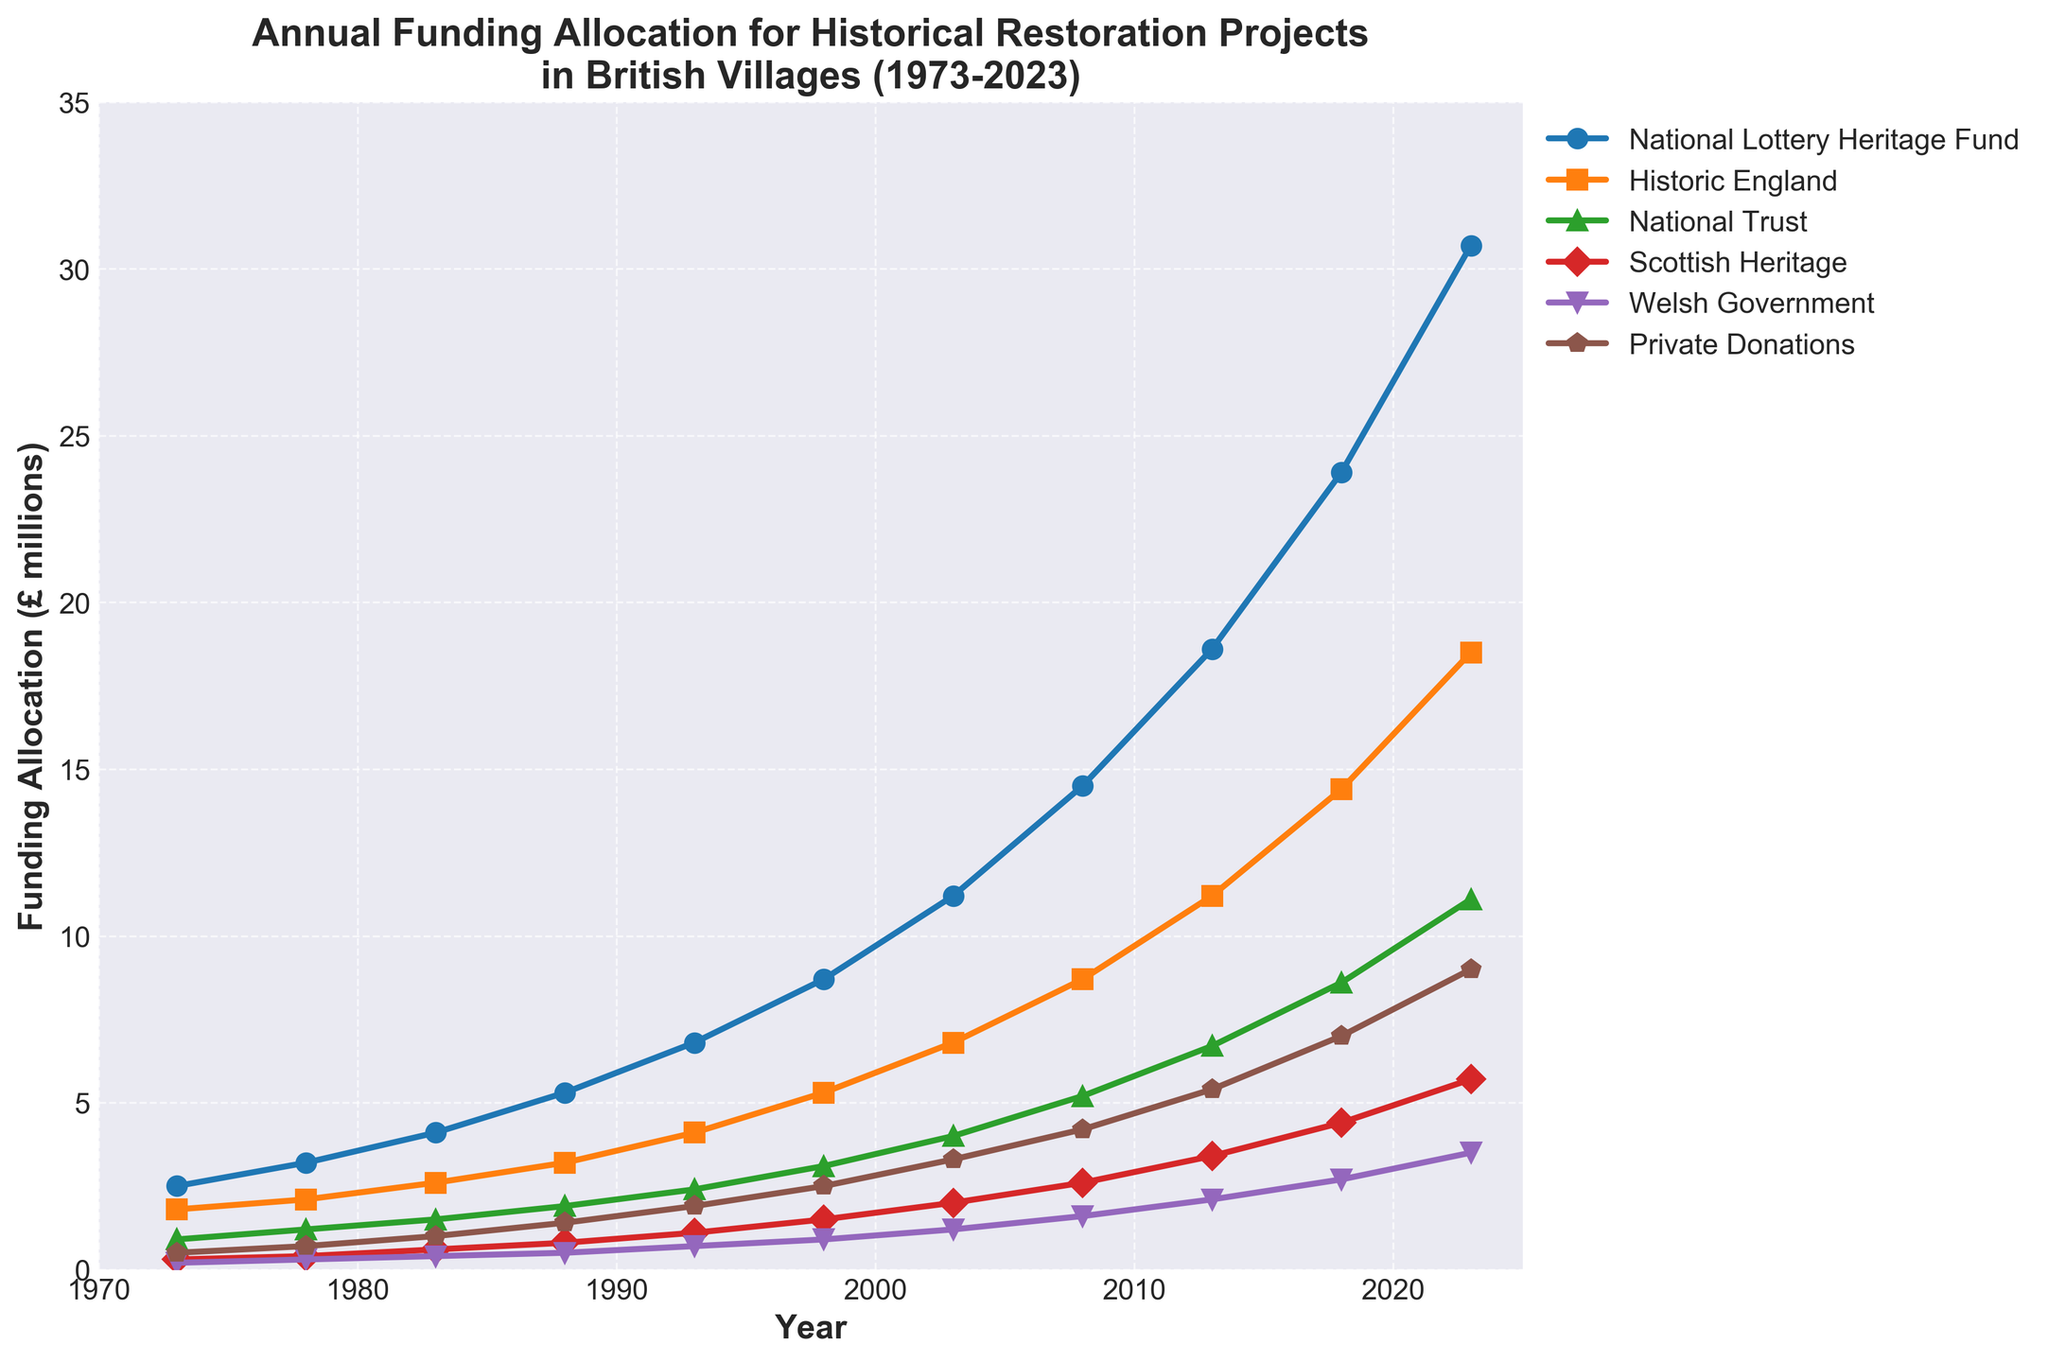What is the total funding allocation for 2023 from all sources combined? Add the funding allocations from each source for the year 2023: £30.7m (National Lottery Heritage Fund) + £18.5m (Historic England) + £11.1m (National Trust) + £5.7m (Scottish Heritage) + £3.5m (Welsh Government) + £9.0m (Private Donations) = £78.5m
Answer: £78.5m Between the National Lottery Heritage Fund and Historic England in 2013, which one had a higher funding allocation and by how much? National Lottery Heritage Fund in 2013 had £18.6m, and Historic England had £11.2m. The difference is £18.6m - £11.2m = £7.4m.
Answer: National Lottery Heritage Fund by £7.4m In which year did the National Trust's funding allocation first exceed £5 million? Look at the National Trust line and identify the first year where the funding crosses £5 million. This occurs in 2008 with £5.2m.
Answer: 2008 How does the trend of Private Donations compare to Welsh Government funding from 1993 to 2023? Both show an upward trend, but Private Donations increase more sharply. In 1993, Private Donations were £1.9m, and Welsh Government was £0.7m. By 2023, Private Donations reached £9.0m, whereas Welsh Government funding increased to £3.5m.
Answer: Private Donations increased more sharply than Welsh Government funding What is the average funding allocation from the National Lottery Heritage Fund between 1973 and 2023? Add all the National Lottery Heritage Fund values: 2.5 + 3.2 + 4.1 + 5.3 + 6.8 + 8.7 + 11.2 + 14.5 + 18.6 + 23.9 + 30.7 = 129.5. Divide by the number of years (11): 129.5 / 11 ≈ 11.77m.
Answer: £11.77m Which funding source shows the least growth over the 50-year period? Compare the initial and final values for each source. Welsh Government grows from £0.2m to £3.5m, the smallest growth.
Answer: Welsh Government In what year did Scottish Heritage funding cross the £3 million mark? Scottish Heritage funding crosses £3 million in 2013 when it was £3.4m.
Answer: 2013 What is the difference in funding allocations for Private Donations between 2003 and 2023? Private Donations in 2003 were £3.3m, and in 2023 it was £9.0m. The difference is £9.0m - £3.3m = £5.7m.
Answer: £5.7m Which funding sources had allocations greater than £10 million in 2018? Check the values for each funding source in 2018. National Lottery Heritage Fund (£23.9m), Historic England (£14.4m), and National Trust (£8.6m) exceed £10 million.
Answer: National Lottery Heritage Fund, Historic England What was the general trend for Historic England funding from 1973 to 2023? The funding for Historic England steadily increased from £1.8m in 1973 to £18.5m in 2023.
Answer: Steady increase 